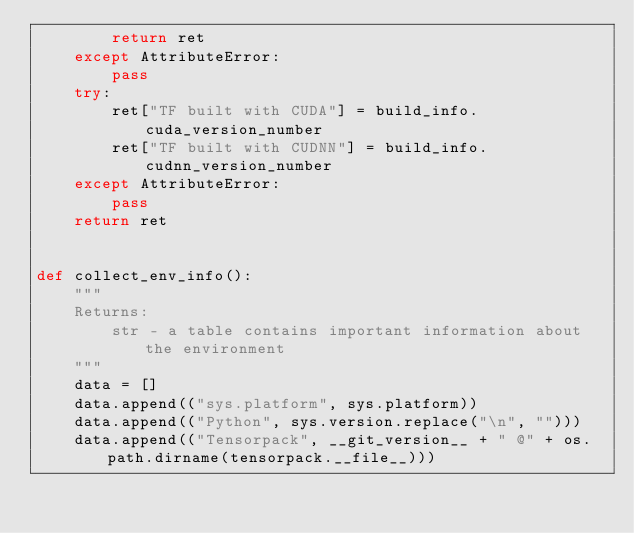Convert code to text. <code><loc_0><loc_0><loc_500><loc_500><_Python_>        return ret
    except AttributeError:
        pass
    try:
        ret["TF built with CUDA"] = build_info.cuda_version_number
        ret["TF built with CUDNN"] = build_info.cudnn_version_number
    except AttributeError:
        pass
    return ret


def collect_env_info():
    """
    Returns:
        str - a table contains important information about the environment
    """
    data = []
    data.append(("sys.platform", sys.platform))
    data.append(("Python", sys.version.replace("\n", "")))
    data.append(("Tensorpack", __git_version__ + " @" + os.path.dirname(tensorpack.__file__)))</code> 